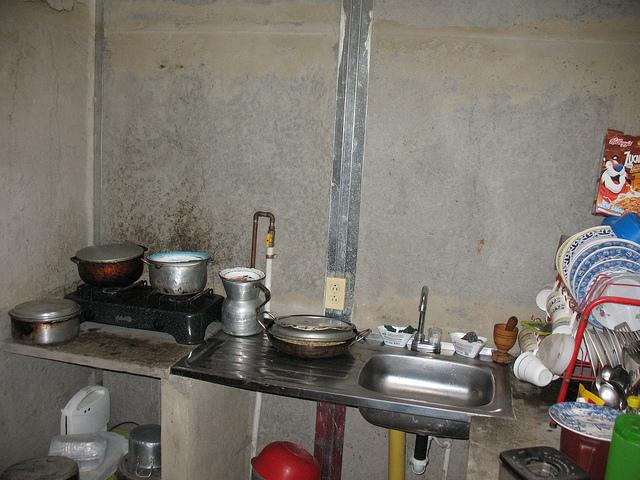Is this picture in a garage?
Give a very brief answer. No. What animal is on the cereal box?
Be succinct. Tiger. Can you see cereal?
Quick response, please. Yes. Are those lines in the pitcher?
Answer briefly. No. 